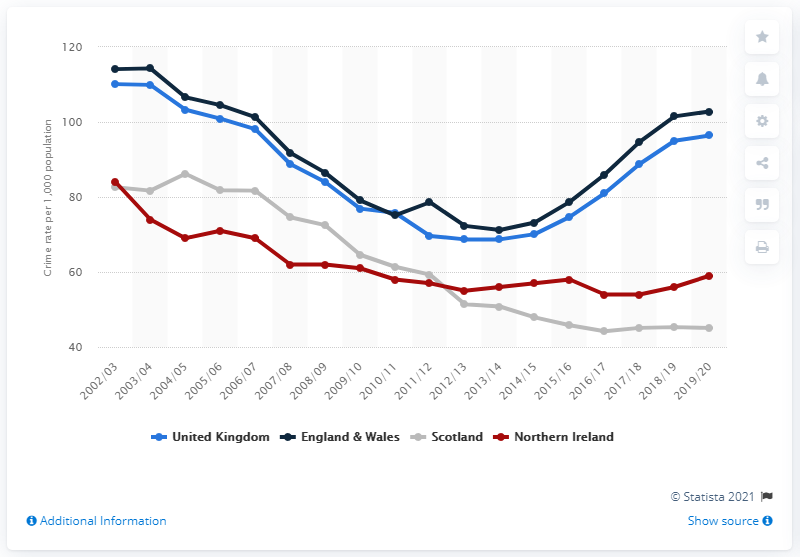Identify some key points in this picture. In the 2019/2020 fiscal year, the crime rate in the United Kingdom was approximately 96.4 crimes per thousand people. Scotland has seen the largest improvement in its crime rate in 2019/20 compared to the previous year. In the year 2002/2003, the crime rate in Scotland was 82.6. 